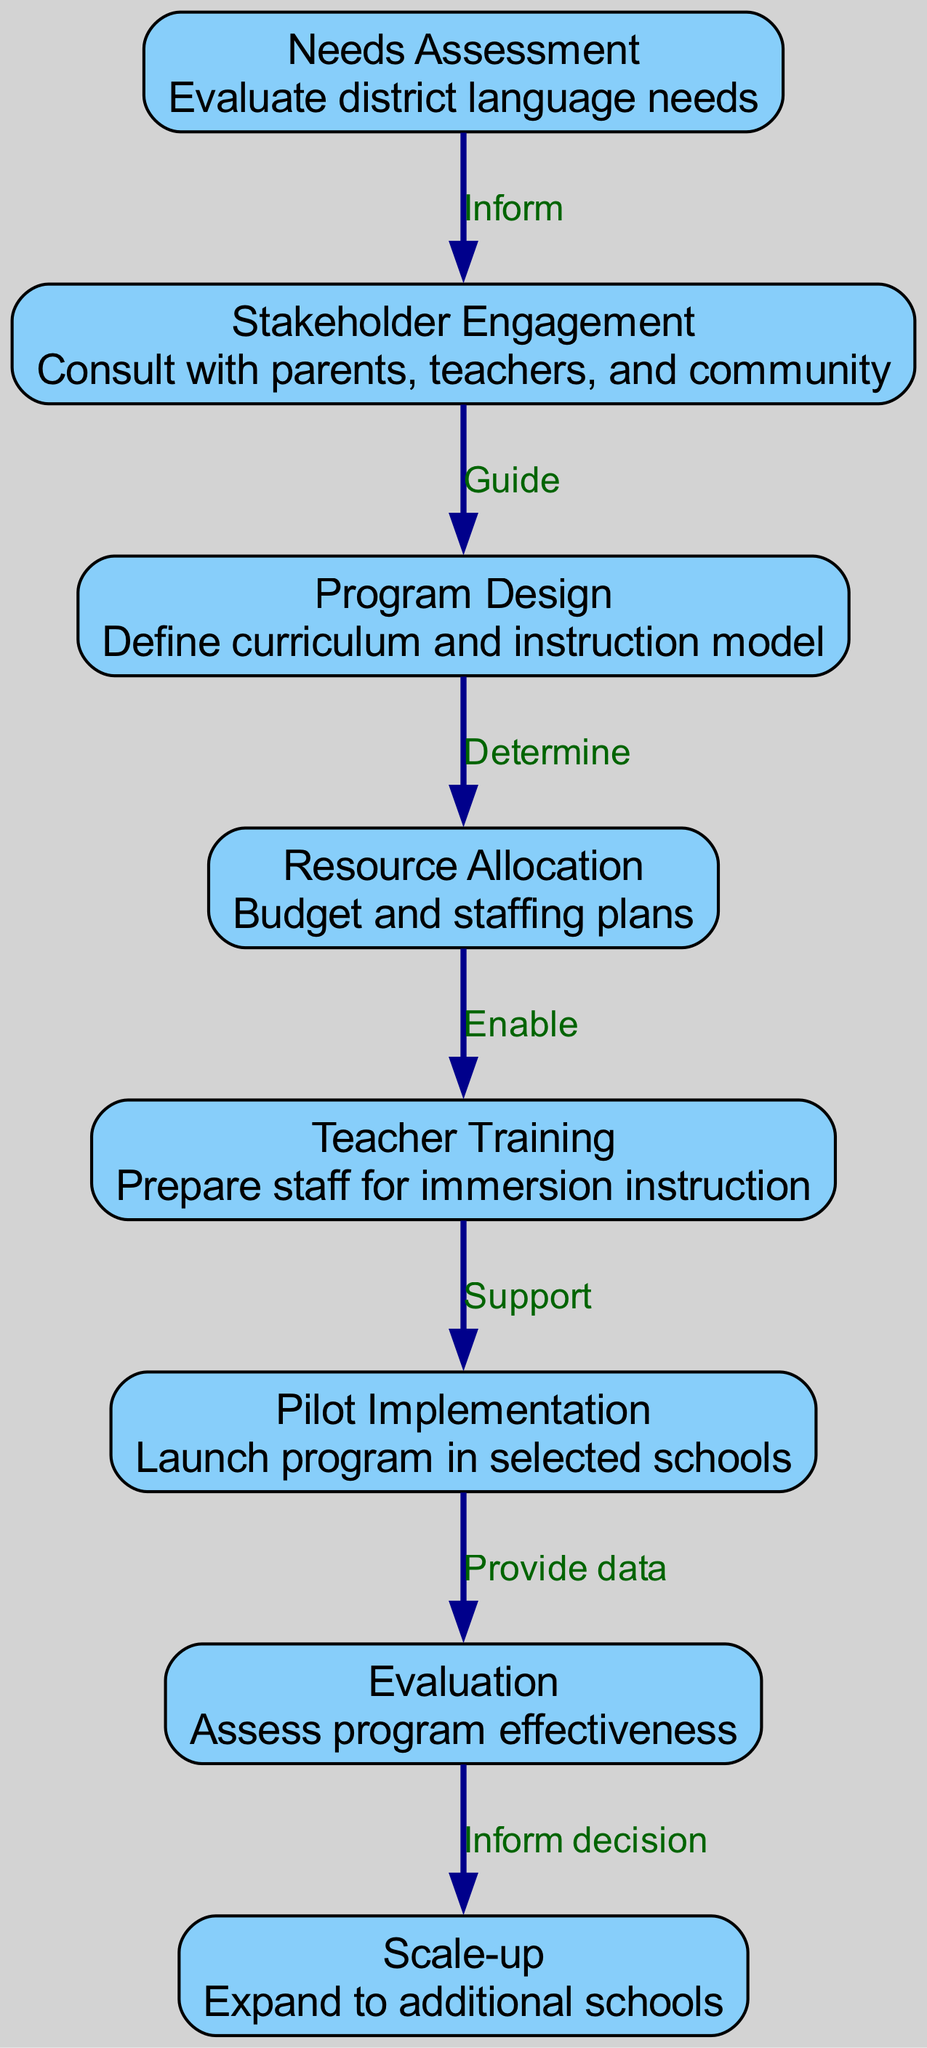What is the first step in the implementation process? The first step is labeled "Needs Assessment," which focuses on evaluating the district's language needs. Since it is the first node in the diagram, it is naturally the initial step.
Answer: Needs Assessment How many nodes are present in the diagram? By counting the nodes listed in the provided data, we find there are eight distinct nodes representing different stages of the process.
Answer: Eight What does the edge from "Evaluation" to "Scale-up" indicate? The edge signifies that the "Evaluation" stage provides information that will inform the decision-making process for the "Scale-up" stage, as indicated by the label "Inform decision."
Answer: Inform decision Which stage follows "Teacher Training"? Referring to the flow of the diagram, "Pilot Implementation" directly follows "Teacher Training," meaning that training occurs before pilot testing begins.
Answer: Pilot Implementation What is the relationship between "Resource Allocation" and "Teacher Training"? The relationship is established by the edge labeled "Enable," indicating that proper resource allocation enables the training of teachers for immersion instruction.
Answer: Enable Which stage involves consulting with stakeholders? The node labeled "Stakeholder Engagement" includes the process of consulting with parents, teachers, and the community, making it clear that this is where stakeholder input is gathered.
Answer: Stakeholder Engagement What is the last stage in the flow diagram? The last stage is labeled "Scale-up," marking the final action of expanding the immersion program to additional schools after evaluation has taken place.
Answer: Scale-up What is assessed during the "Evaluation" stage? The evaluation stage is focused on assessing the effectiveness of the immersion program, ensuring it meets the intended objectives and outcomes.
Answer: Program effectiveness Which node follows "Pilot Implementation"? The node that follows "Pilot Implementation" is "Evaluation," where the program's effectiveness will be assessed after the pilot phase has been completed.
Answer: Evaluation 